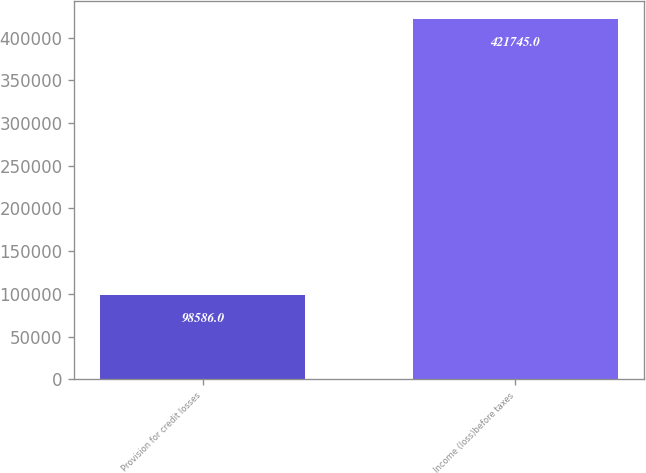Convert chart. <chart><loc_0><loc_0><loc_500><loc_500><bar_chart><fcel>Provision for credit losses<fcel>Income (loss)before taxes<nl><fcel>98586<fcel>421745<nl></chart> 